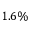<formula> <loc_0><loc_0><loc_500><loc_500>1 . 6 \%</formula> 